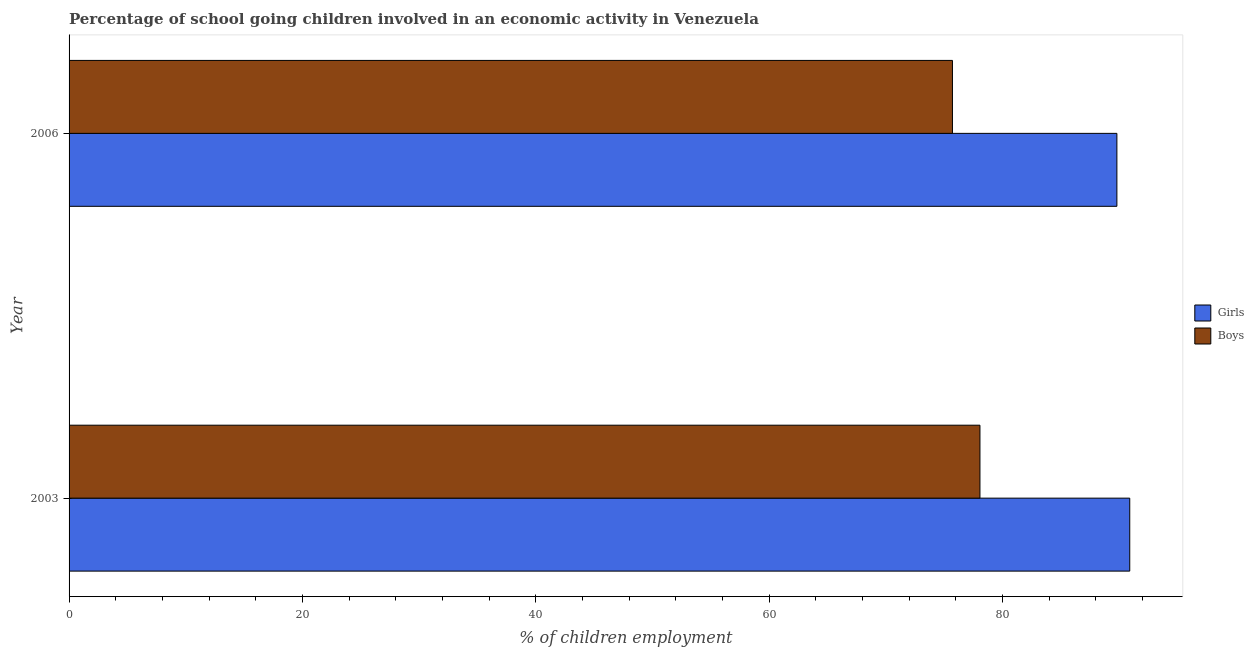How many different coloured bars are there?
Give a very brief answer. 2. Are the number of bars per tick equal to the number of legend labels?
Provide a succinct answer. Yes. How many bars are there on the 1st tick from the top?
Offer a terse response. 2. What is the label of the 1st group of bars from the top?
Make the answer very short. 2006. What is the percentage of school going boys in 2006?
Provide a short and direct response. 75.71. Across all years, what is the maximum percentage of school going girls?
Make the answer very short. 90.91. Across all years, what is the minimum percentage of school going boys?
Ensure brevity in your answer.  75.71. In which year was the percentage of school going girls maximum?
Your response must be concise. 2003. In which year was the percentage of school going girls minimum?
Keep it short and to the point. 2006. What is the total percentage of school going girls in the graph?
Your answer should be compact. 180.72. What is the difference between the percentage of school going girls in 2003 and that in 2006?
Your response must be concise. 1.1. What is the difference between the percentage of school going boys in 2003 and the percentage of school going girls in 2006?
Provide a succinct answer. -11.74. What is the average percentage of school going boys per year?
Provide a succinct answer. 76.89. In the year 2003, what is the difference between the percentage of school going girls and percentage of school going boys?
Provide a short and direct response. 12.84. In how many years, is the percentage of school going girls greater than 80 %?
Ensure brevity in your answer.  2. What is the ratio of the percentage of school going boys in 2003 to that in 2006?
Make the answer very short. 1.03. In how many years, is the percentage of school going boys greater than the average percentage of school going boys taken over all years?
Make the answer very short. 1. What does the 2nd bar from the top in 2006 represents?
Keep it short and to the point. Girls. What does the 2nd bar from the bottom in 2006 represents?
Make the answer very short. Boys. Are all the bars in the graph horizontal?
Make the answer very short. Yes. How many years are there in the graph?
Keep it short and to the point. 2. How are the legend labels stacked?
Your response must be concise. Vertical. What is the title of the graph?
Your answer should be compact. Percentage of school going children involved in an economic activity in Venezuela. What is the label or title of the X-axis?
Your answer should be compact. % of children employment. What is the % of children employment of Girls in 2003?
Your response must be concise. 90.91. What is the % of children employment of Boys in 2003?
Provide a succinct answer. 78.07. What is the % of children employment of Girls in 2006?
Your response must be concise. 89.81. What is the % of children employment in Boys in 2006?
Provide a succinct answer. 75.71. Across all years, what is the maximum % of children employment of Girls?
Make the answer very short. 90.91. Across all years, what is the maximum % of children employment in Boys?
Offer a very short reply. 78.07. Across all years, what is the minimum % of children employment of Girls?
Your answer should be compact. 89.81. Across all years, what is the minimum % of children employment of Boys?
Provide a succinct answer. 75.71. What is the total % of children employment in Girls in the graph?
Your answer should be compact. 180.72. What is the total % of children employment of Boys in the graph?
Offer a very short reply. 153.78. What is the difference between the % of children employment in Girls in 2003 and that in 2006?
Offer a very short reply. 1.1. What is the difference between the % of children employment of Boys in 2003 and that in 2006?
Your answer should be compact. 2.36. What is the difference between the % of children employment in Girls in 2003 and the % of children employment in Boys in 2006?
Keep it short and to the point. 15.2. What is the average % of children employment in Girls per year?
Your answer should be compact. 90.36. What is the average % of children employment in Boys per year?
Offer a terse response. 76.89. In the year 2003, what is the difference between the % of children employment in Girls and % of children employment in Boys?
Offer a terse response. 12.84. In the year 2006, what is the difference between the % of children employment in Girls and % of children employment in Boys?
Your answer should be compact. 14.09. What is the ratio of the % of children employment in Girls in 2003 to that in 2006?
Provide a short and direct response. 1.01. What is the ratio of the % of children employment of Boys in 2003 to that in 2006?
Keep it short and to the point. 1.03. What is the difference between the highest and the second highest % of children employment in Girls?
Give a very brief answer. 1.1. What is the difference between the highest and the second highest % of children employment in Boys?
Provide a succinct answer. 2.36. What is the difference between the highest and the lowest % of children employment in Girls?
Make the answer very short. 1.1. What is the difference between the highest and the lowest % of children employment in Boys?
Your answer should be compact. 2.36. 